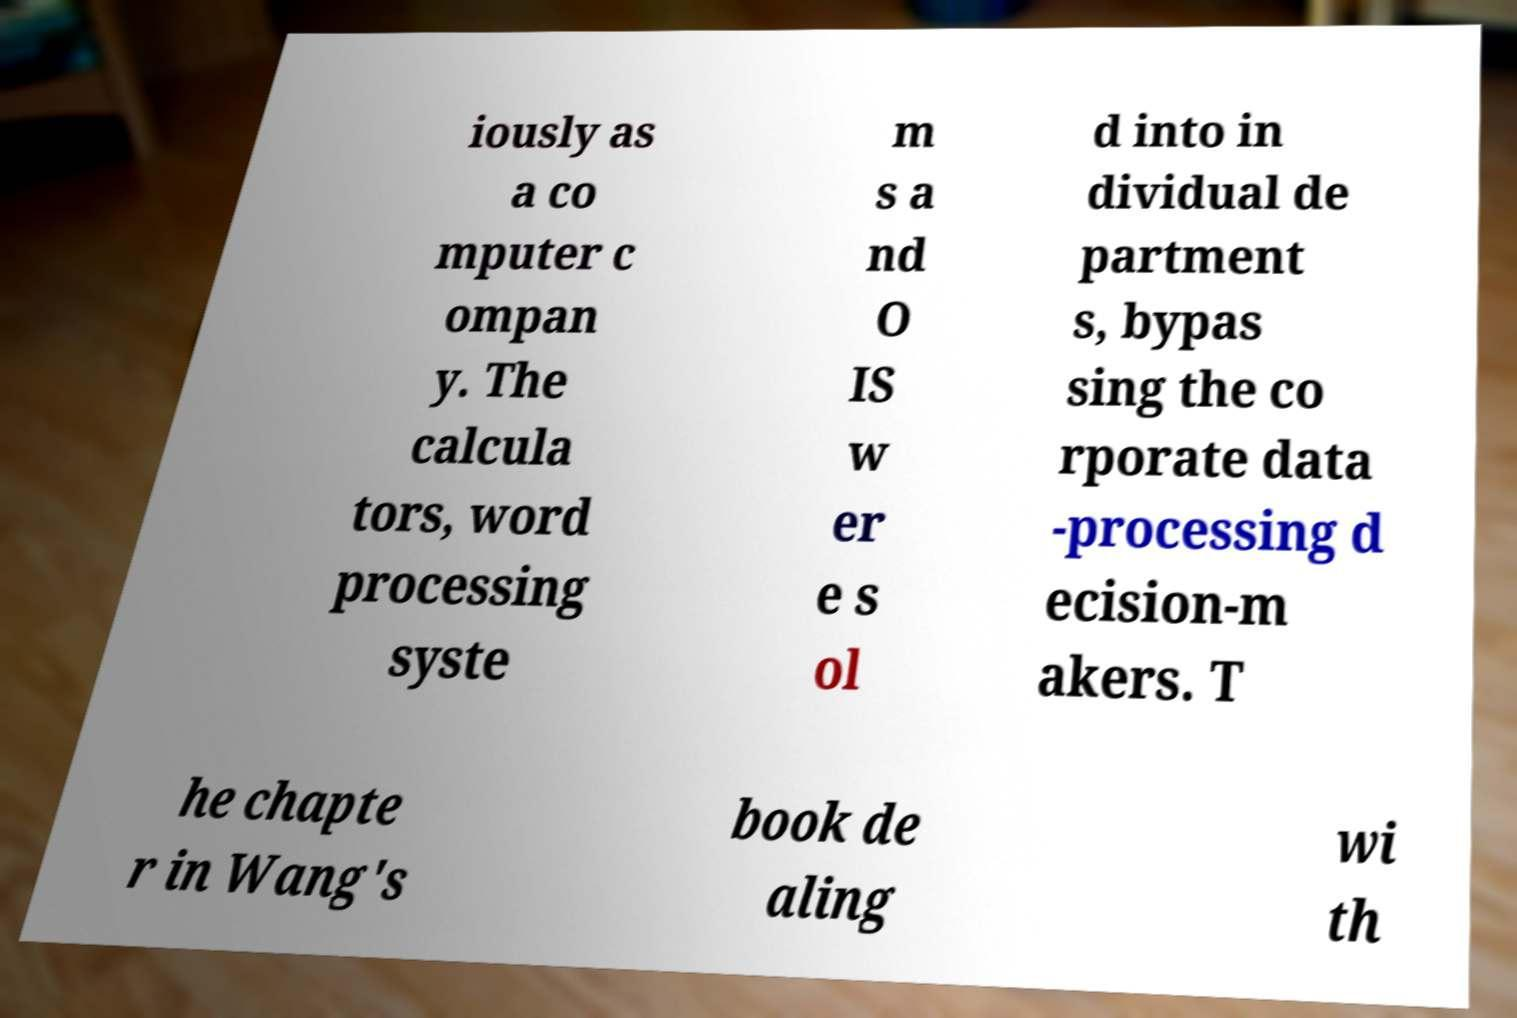There's text embedded in this image that I need extracted. Can you transcribe it verbatim? iously as a co mputer c ompan y. The calcula tors, word processing syste m s a nd O IS w er e s ol d into in dividual de partment s, bypas sing the co rporate data -processing d ecision-m akers. T he chapte r in Wang's book de aling wi th 